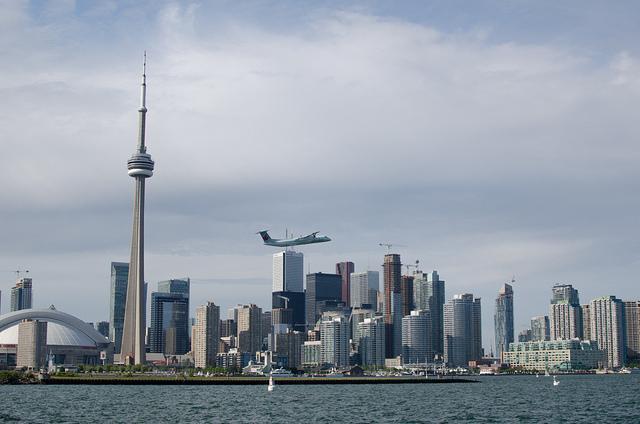How many people are playing tennis in the image?
Give a very brief answer. 0. 